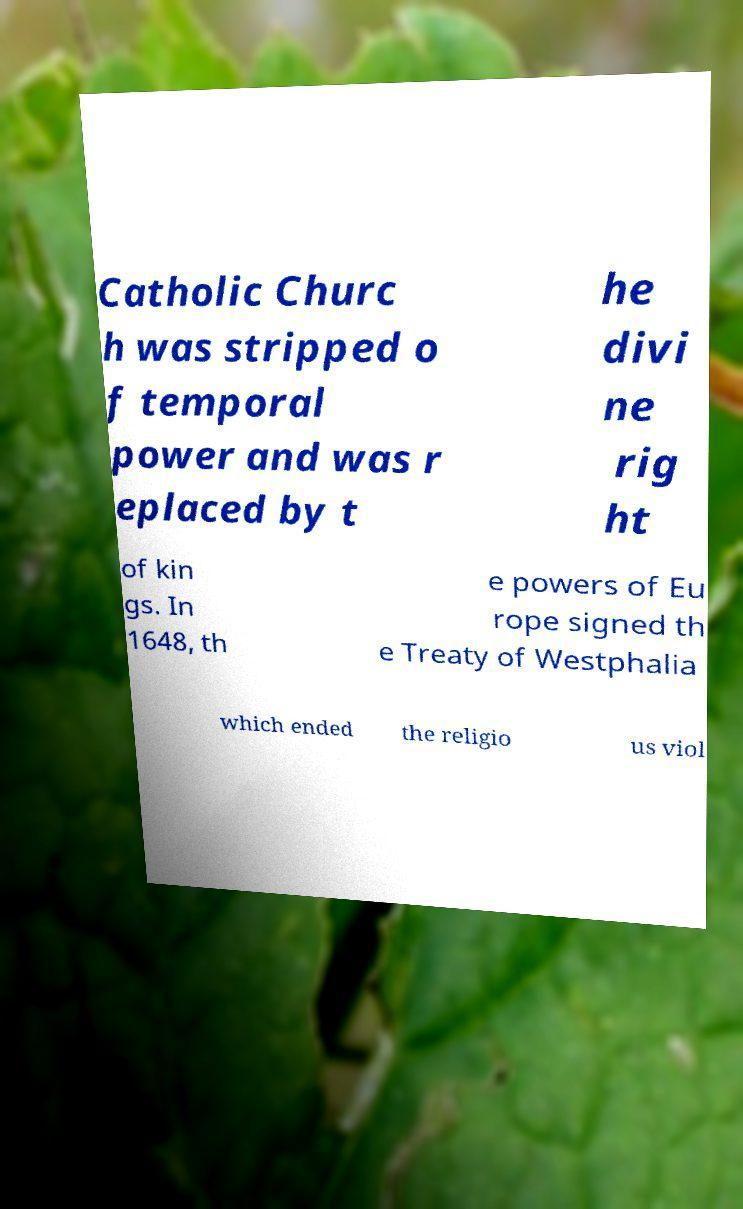Please read and relay the text visible in this image. What does it say? Catholic Churc h was stripped o f temporal power and was r eplaced by t he divi ne rig ht of kin gs. In 1648, th e powers of Eu rope signed th e Treaty of Westphalia which ended the religio us viol 